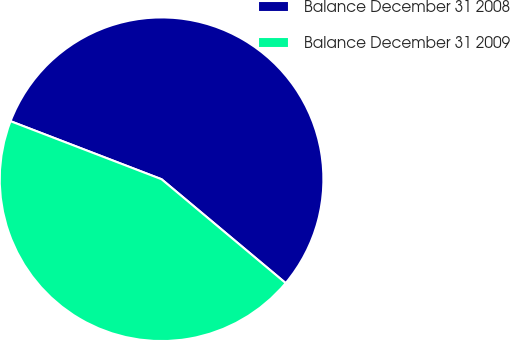Convert chart to OTSL. <chart><loc_0><loc_0><loc_500><loc_500><pie_chart><fcel>Balance December 31 2008<fcel>Balance December 31 2009<nl><fcel>55.25%<fcel>44.75%<nl></chart> 